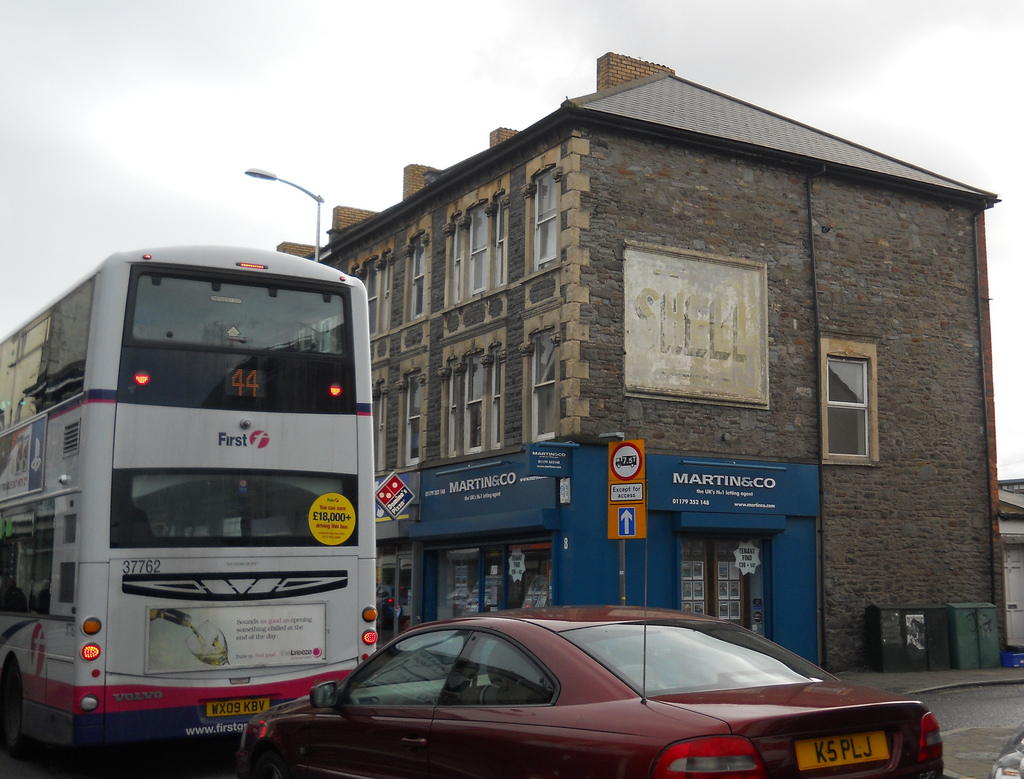What do you see in this image? The image shows a busy street corner with a mix of modern and older elements. There's a white double-decker bus labeled 'First' with a visible route number '44'. A maroon sedan is also seen, its license plate 'K5 PLJ'. The brick building has an old, faded 'SHELL' sign and several windows. The ground floor has a MARTIN&CO office, a Domino's Pizza sign, and a few other storefronts. Describe the architecture of the buildings. The architecture of the buildings showcases an older, classic brick design. The multi-story brick building has a distinct historic charm with its aged 'SHELL' sign, indicative of a bygone era. The structure features rectangular windows with stone frames, adding to the sturdy and enduring aesthetic. The MARTIN&CO office on the ground floor brings a touch of modernity with its crisp, blue exterior and clear signage, reflecting the blend of historical and contemporary elements in the urban landscape. Imagine the bus was instead a spaceship and the scene was set on a different planet. Describe the scene. In an alternate universe, the street corner is a bustling hub on the vibrant planet of Xenon Prime. Instead of the white double-decker bus, a sleek, silver spaceship hovers silently, its bright '44' route number glowing in a neon blue. The vehicle emits a faint hum as it levitates, ready to whisk passengers to distant corners of the galaxy.

The old brick building has transformed into a towering spire of translucent materials, shimmering with ethereal lights. The faded 'SHELL' sign is now a holographic display, advertising a popular interstellar fuel brand. The windows are port-holes, giving glimpses into advanced, high-tech interiors with floating furniture and holographic assistants.

On the ground, the MARTIN&CO office is now a futuristic real estate agency, selling luxurious domes and floating villas on exotic moons. The Domino's Pizza sign has evolved into a transparent booth, where pizzas are synthesized instantly from molecular ingredients, promising gastronomic delights in seconds.

The maroon sedan is no longer bound to the pavement; it has morphed into a sleek hovercar, gliding a few feet above the ground, its license plate 'K5 PLJ' still visible but now glowing with luminescent colors.

The scene is abuzz with an eclectic mix of aliens and humans, each going about their cosmic business. The air is filled with a mix of foreign languages, digital beeps, and the distant sound of cosmic waves, creating a harmonious blend of advanced technology and interstellar culture. Imagine this scene moments before a sudden summer rainstorm. Moments before a sudden summer rainstorm, the scene is tranquil yet charged with anticipation. The air is thick and humid, with dark clouds gathering ominously above. The streets, bathed in the golden hue of the setting sun, seem to hold their breath.

The bus is stationary, passengers disembarking quickly, sensing the impending downpour. The brick building's windows reflect the darkening sky, and the old 'SHELL' sign appears even more worn against the backdrop of the turbulent weather.

People hurry past the MARTIN&CO office, seeking shelter in nearby shops. The Domino's Pizza sign shines more brightly against the encroaching gloom, a beacon of warmth and dryness. The maroon sedan's driver hastens to roll up the windows, ready to escape the coming deluge.

The first fat drops of rain splash onto the pavement, sending ripples through the puddles. The atmosphere is charged, holding the promise of rain's refreshing coolness and the earthy scent that will soon fill the air. The city is on the cusp of transformation, teetering between calm and chaos. Imagine this scene at the start of a busy workday. At the start of a busy workday, the scene is lively and full of energy. The bus is packed with commuters, its doors opening and closing rapidly to accommodate the morning rush. The building's windows begin to light up as businesses inside come to life.

People in suits and everyday work attire bustle in and out of the MARTIN&CO office, briefcases in hand. The Domino's Pizza sign is less prominent, overshadowed by the stir of activity. The maroon sedan is parked neatly, waiting for its owner to start their workday.

The street is filled with movement, sounds of footsteps, and snippets of conversation as everyone heads to their destinations. The scent of fresh coffee wafts through the air from a nearby café, adding to the morning vibrancy. It's the beginning of another productive day in the city, full of promise and purpose. 